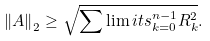<formula> <loc_0><loc_0><loc_500><loc_500>{ { \left \| { A } \right \| } _ { 2 } } \geq \sqrt { \sum \lim i t s _ { k = 0 } ^ { n - 1 } { R _ { k } ^ { 2 } } } .</formula> 